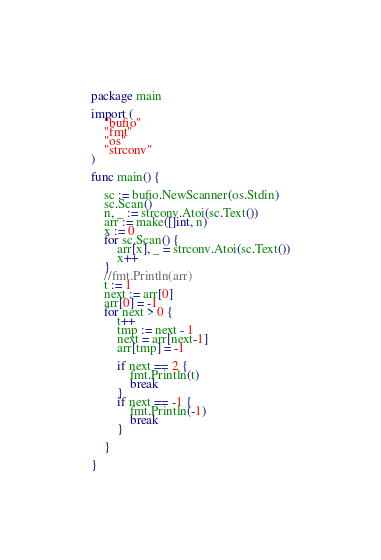Convert code to text. <code><loc_0><loc_0><loc_500><loc_500><_Go_>package main

import (
	"bufio"
	"fmt"
	"os"
	"strconv"
)

func main() {

	sc := bufio.NewScanner(os.Stdin)
	sc.Scan()
	n, _ := strconv.Atoi(sc.Text())
	arr := make([]int, n)
	x := 0
	for sc.Scan() {
		arr[x], _ = strconv.Atoi(sc.Text())
		x++
	}
	//fmt.Println(arr)
	t := 1
	next := arr[0]
	arr[0] = -1
	for next > 0 {
		t++
		tmp := next - 1
		next = arr[next-1]
		arr[tmp] = -1

		if next == 2 {
			fmt.Println(t)
			break
		}
		if next == -1 {
			fmt.Println(-1)
			break
		}

	}

}
</code> 